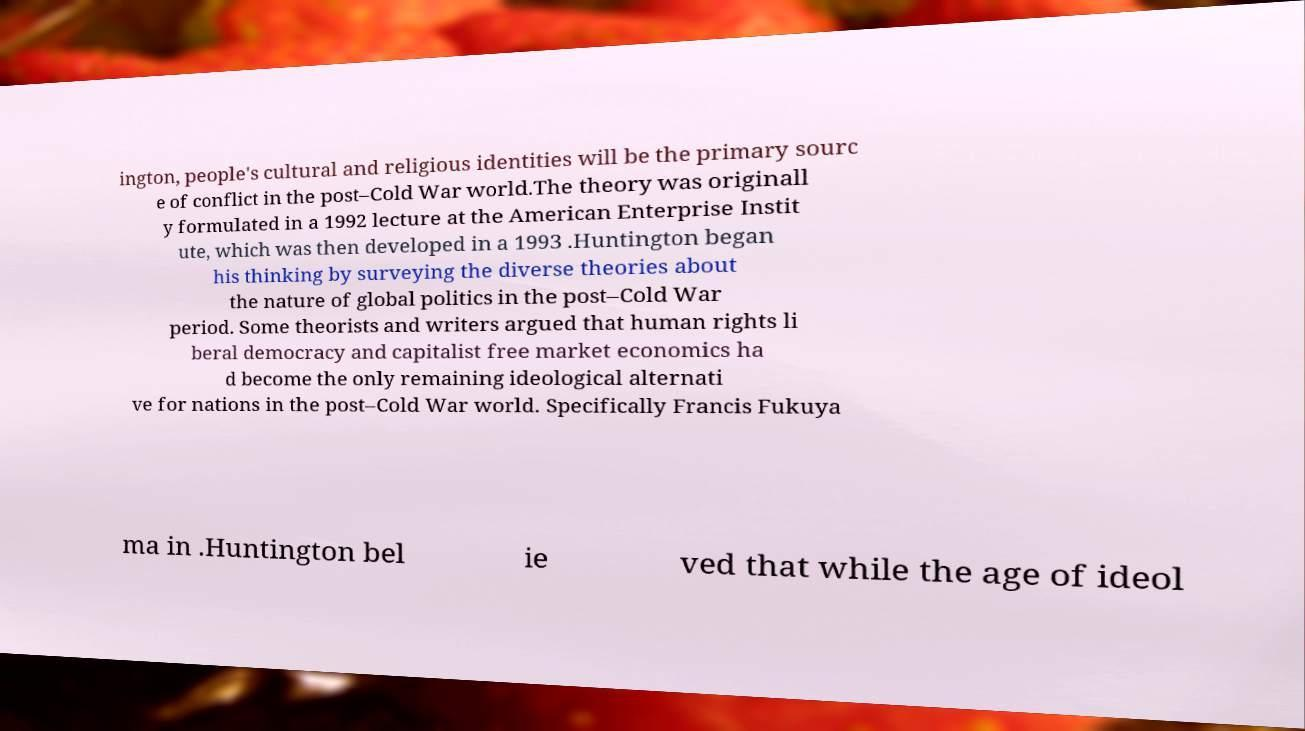There's text embedded in this image that I need extracted. Can you transcribe it verbatim? ington, people's cultural and religious identities will be the primary sourc e of conflict in the post–Cold War world.The theory was originall y formulated in a 1992 lecture at the American Enterprise Instit ute, which was then developed in a 1993 .Huntington began his thinking by surveying the diverse theories about the nature of global politics in the post–Cold War period. Some theorists and writers argued that human rights li beral democracy and capitalist free market economics ha d become the only remaining ideological alternati ve for nations in the post–Cold War world. Specifically Francis Fukuya ma in .Huntington bel ie ved that while the age of ideol 